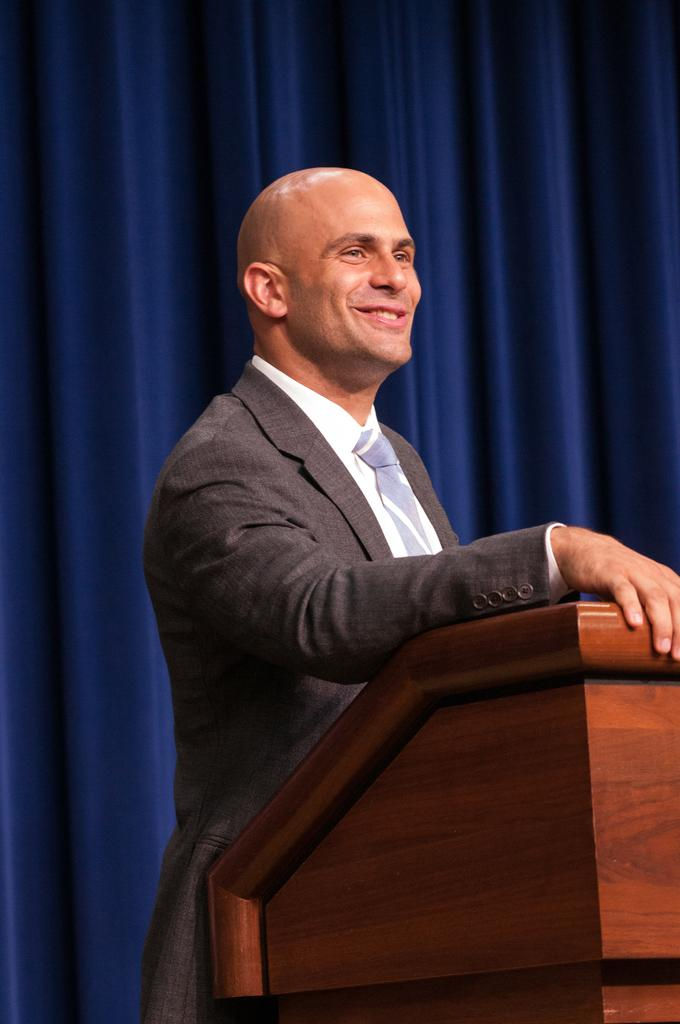What is the main subject in the foreground of the picture? There is a person standing near a podium in the foreground of the picture. What is the person wearing? The person is wearing a grey suit. What can be seen in the background of the picture? There is a blue curtain in the background of the picture. What type of error can be seen on the podium in the image? There is no error visible on the podium in the image. Is there a volcano erupting in the background of the image? There is no volcano present in the image; it features a person standing near a podium and a blue curtain in the background. 